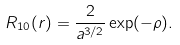Convert formula to latex. <formula><loc_0><loc_0><loc_500><loc_500>R _ { 1 0 } ( r ) = \frac { 2 } { a ^ { 3 / 2 } } \exp ( - \rho ) .</formula> 